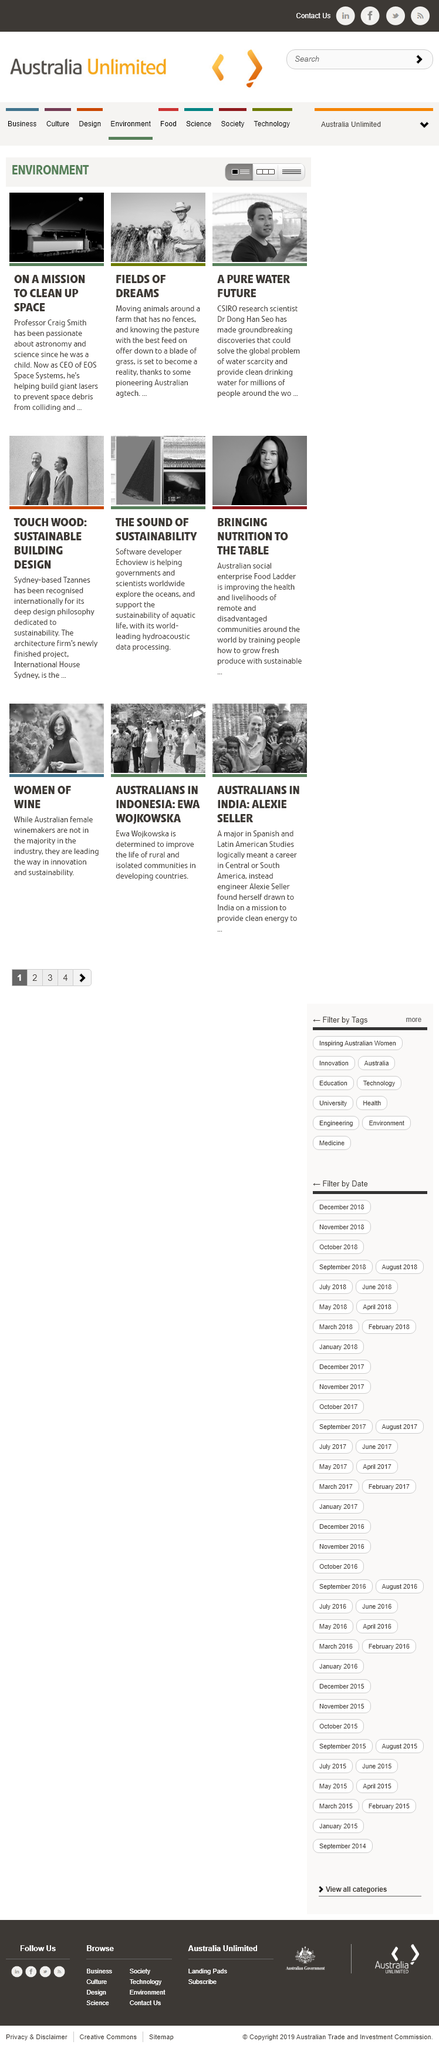Draw attention to some important aspects in this diagram. The discovery of a new type of membrane that can separate water molecules based on their polarity could potentially solve the issue of water scarcity and provide clean drinking water for millions of people around the world. Professor Craig Smith is the CEO of EOS Space Systems. The man in the third picture is Dr. Dong Han Seo. 